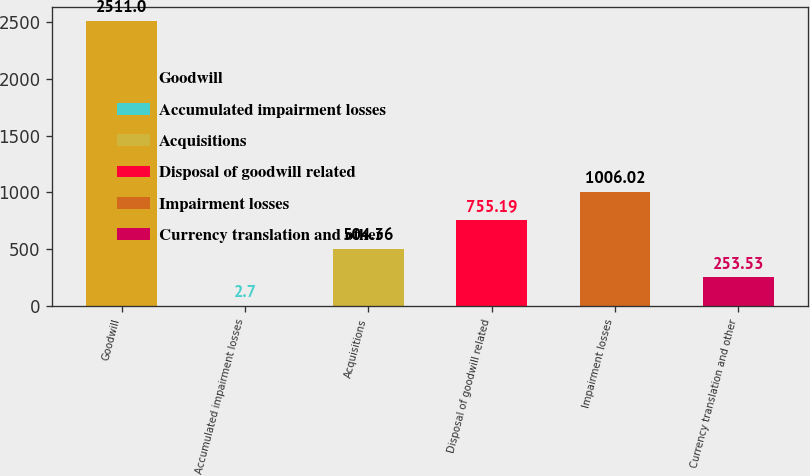Convert chart. <chart><loc_0><loc_0><loc_500><loc_500><bar_chart><fcel>Goodwill<fcel>Accumulated impairment losses<fcel>Acquisitions<fcel>Disposal of goodwill related<fcel>Impairment losses<fcel>Currency translation and other<nl><fcel>2511<fcel>2.7<fcel>504.36<fcel>755.19<fcel>1006.02<fcel>253.53<nl></chart> 